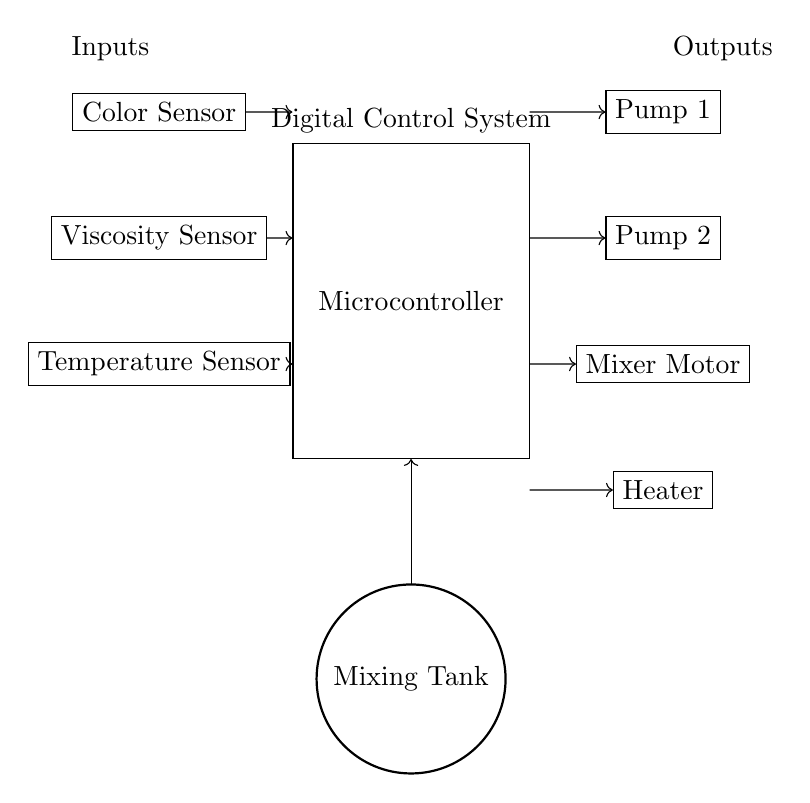What is the primary component controlling the system? The microcontroller is the central component responsible for processing sensor inputs and controlling the outputs. It receives data from the sensors and sends commands to the actuators.
Answer: Microcontroller How many sensors are present in the circuit? There are three sensors present in the circuit: a color sensor, a viscosity sensor, and a temperature sensor. Each sensor serves a specific purpose in monitoring the characteristics of the pigment mixture.
Answer: Three Which component receives data from the temperature sensor? The microcontroller receives data from the temperature sensor. This connection allows the microcontroller to process temperature information to control other components like the heater.
Answer: Microcontroller What is the purpose of the mixer motor in the circuit? The mixer motor's purpose is to blend the pigment materials thoroughly, ensuring even consistency and color distribution. It is activated based on the microcontroller's commands.
Answer: Blend pigments What actions does the microcontroller take based on the input from the viscosity sensor? The microcontroller analyzes the viscosity data to determine if the mixture needs adjustments, triggering the appropriate pumps or mixer to achieve the desired viscosity level.
Answer: Adjust mixture Name the output components controlled by the microcontroller. The output components are Pump 1, Pump 2, Mixer Motor, and Heater. These components are activated or modified based on the inputs received by the microcontroller for optimal pigment mixing.
Answer: Pump 1, Pump 2, Mixer Motor, Heater 